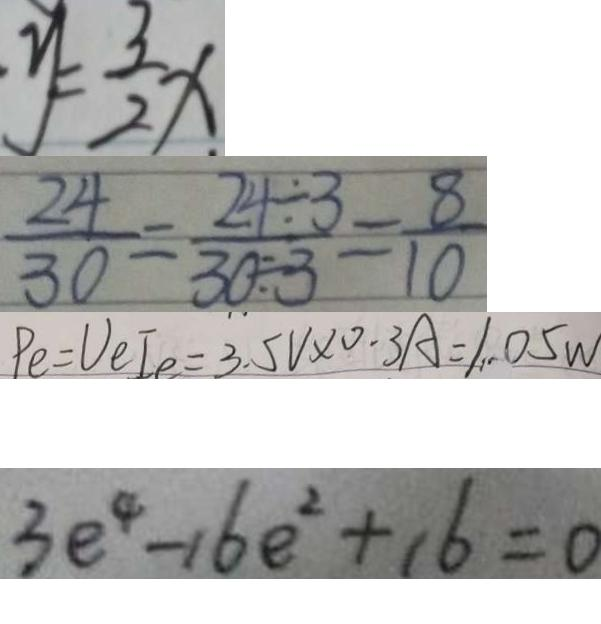Convert formula to latex. <formula><loc_0><loc_0><loc_500><loc_500>y = \frac { 3 } { 2 } x 
 \frac { 2 4 } { 3 0 } = \frac { 2 4 \div 3 } { 3 0 \div 3 } = \frac { 8 } { 1 0 } 
 P _ { e } = U _ { e } I e = 3 . 5 V \times 0 . 3 A = 1 . 0 5 w 
 3 e ^ { 4 } - 1 6 e ^ { 2 } + 1 6 = 0</formula> 